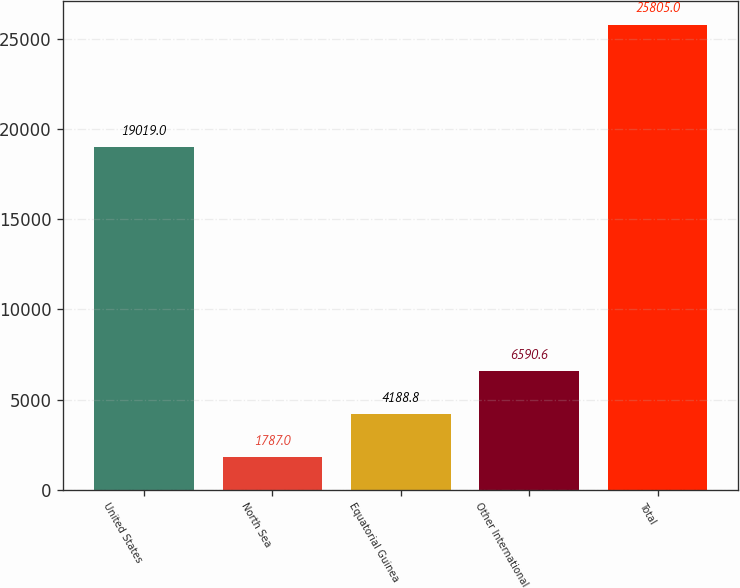Convert chart to OTSL. <chart><loc_0><loc_0><loc_500><loc_500><bar_chart><fcel>United States<fcel>North Sea<fcel>Equatorial Guinea<fcel>Other International<fcel>Total<nl><fcel>19019<fcel>1787<fcel>4188.8<fcel>6590.6<fcel>25805<nl></chart> 